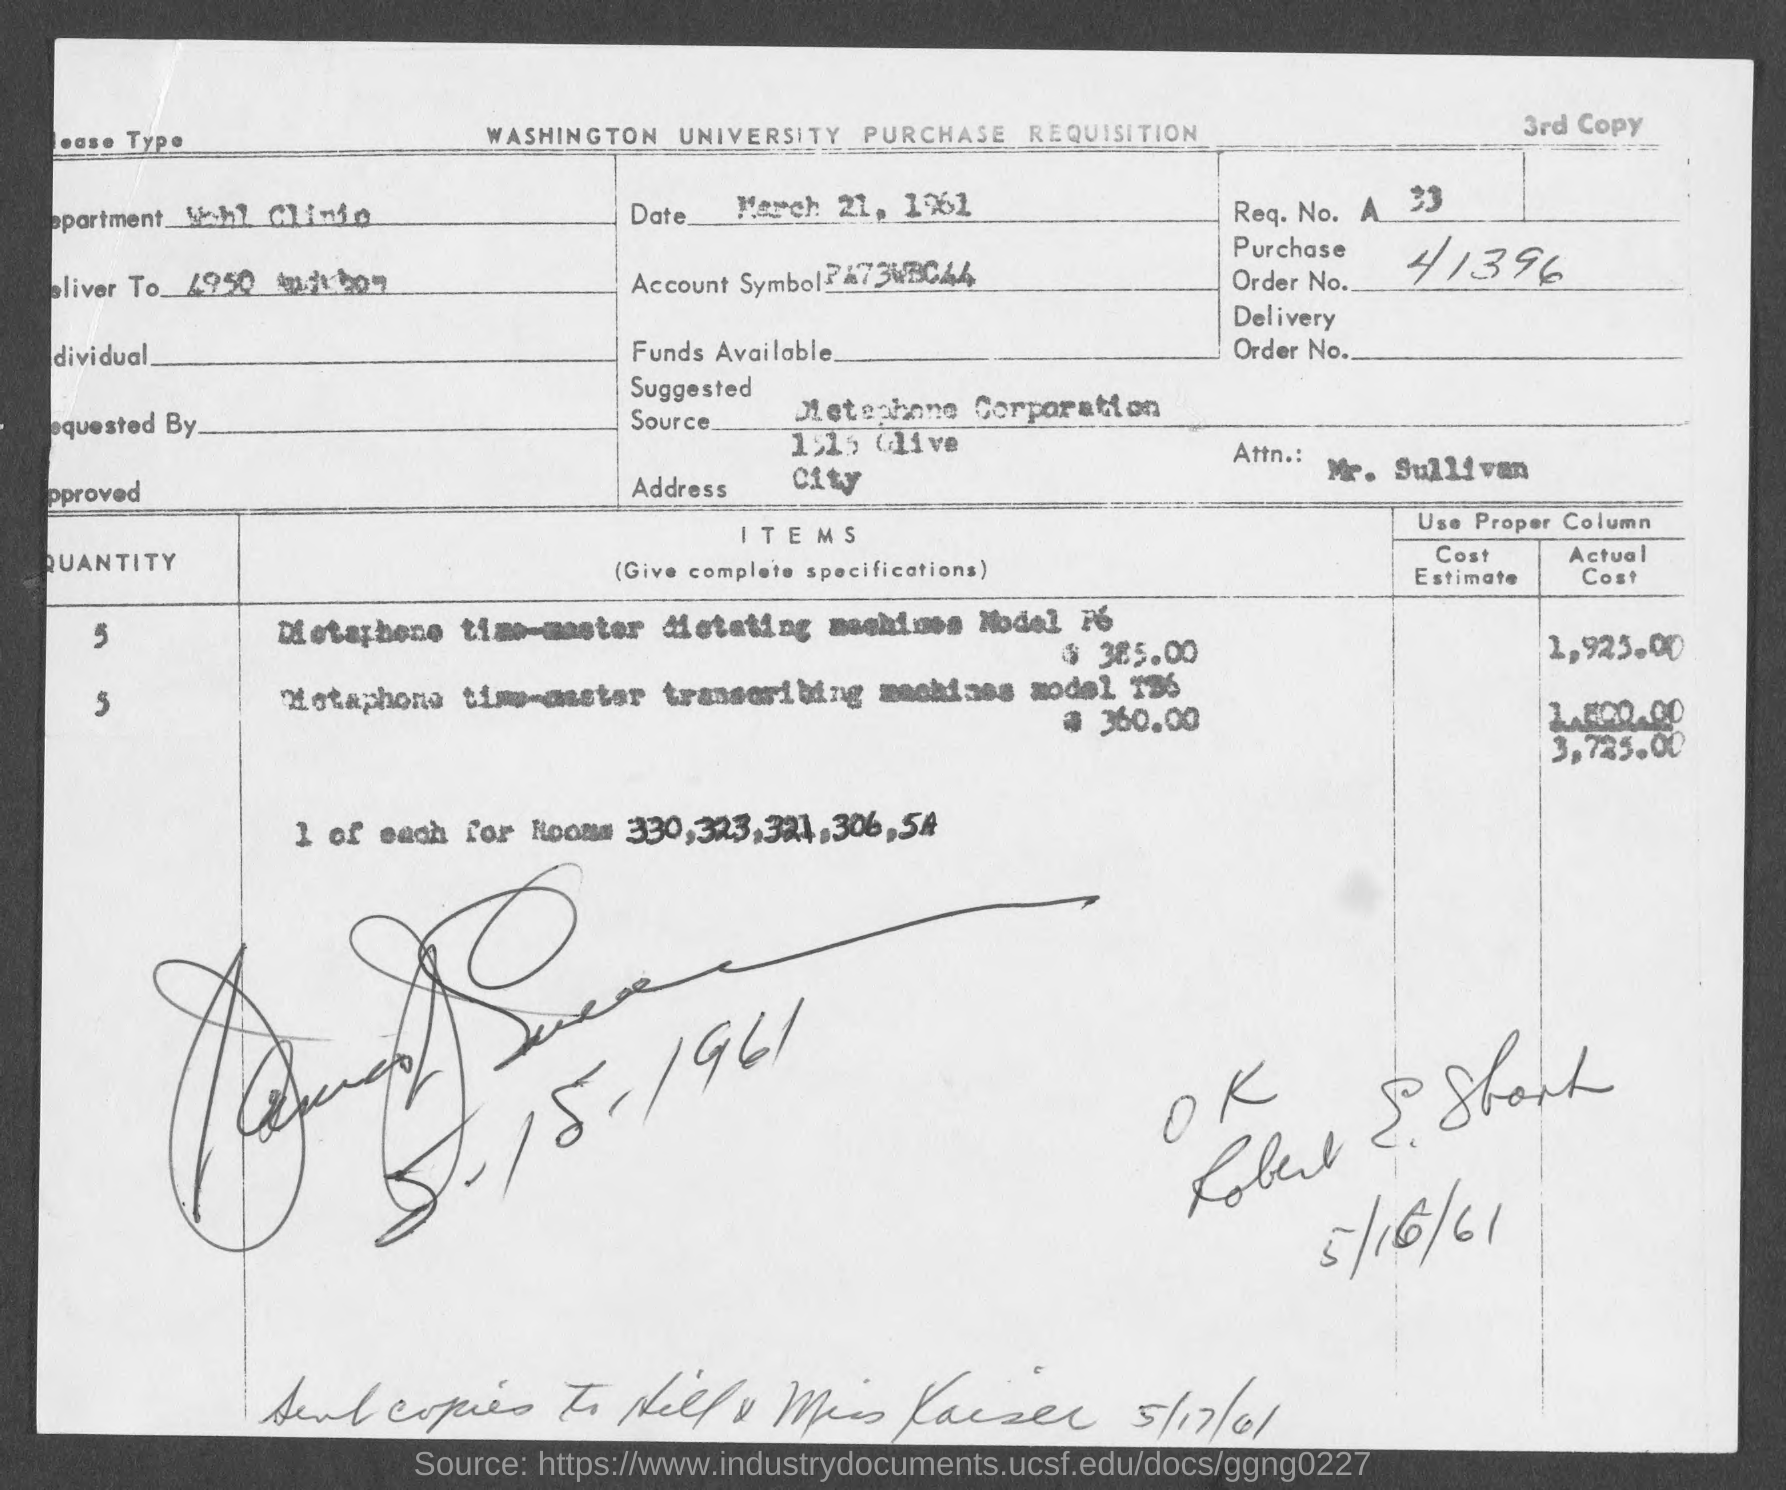List a handful of essential elements in this visual. The account symbol mentioned in the document is "PA73WBC44..". According to the document, the total actual cost is 3,725... The document contains a purchase order number, 41396. The request number mentioned in the document is 33.. 